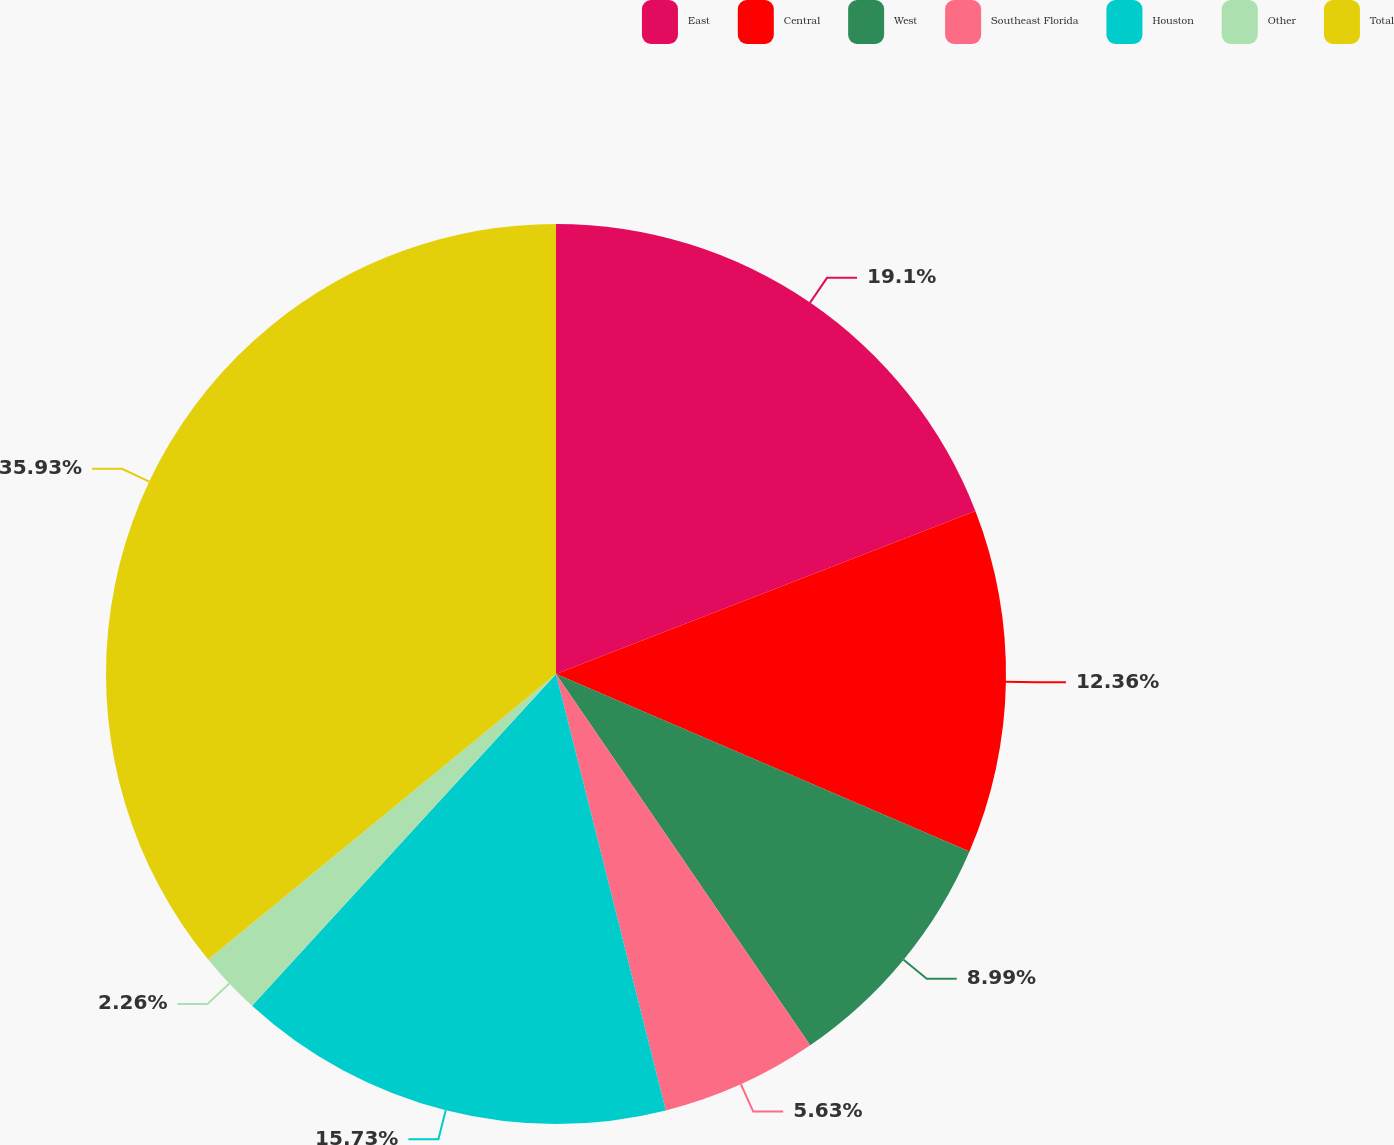<chart> <loc_0><loc_0><loc_500><loc_500><pie_chart><fcel>East<fcel>Central<fcel>West<fcel>Southeast Florida<fcel>Houston<fcel>Other<fcel>Total<nl><fcel>19.1%<fcel>12.36%<fcel>8.99%<fcel>5.63%<fcel>15.73%<fcel>2.26%<fcel>35.94%<nl></chart> 